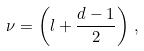<formula> <loc_0><loc_0><loc_500><loc_500>\nu = \left ( l + \frac { d - 1 } { 2 } \right ) \, ,</formula> 